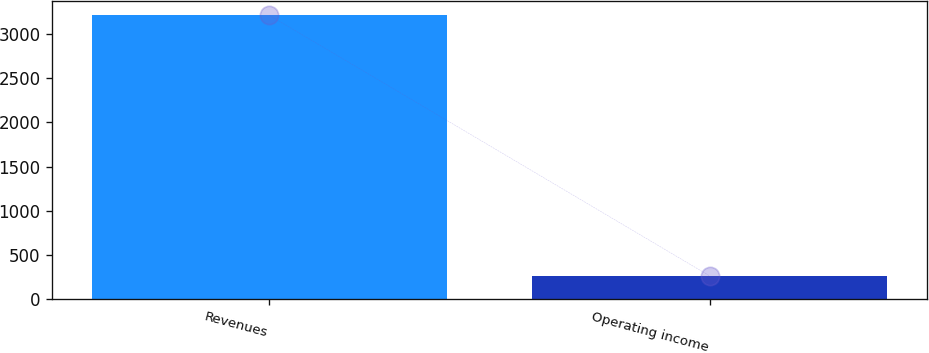Convert chart to OTSL. <chart><loc_0><loc_0><loc_500><loc_500><bar_chart><fcel>Revenues<fcel>Operating income<nl><fcel>3210<fcel>263<nl></chart> 